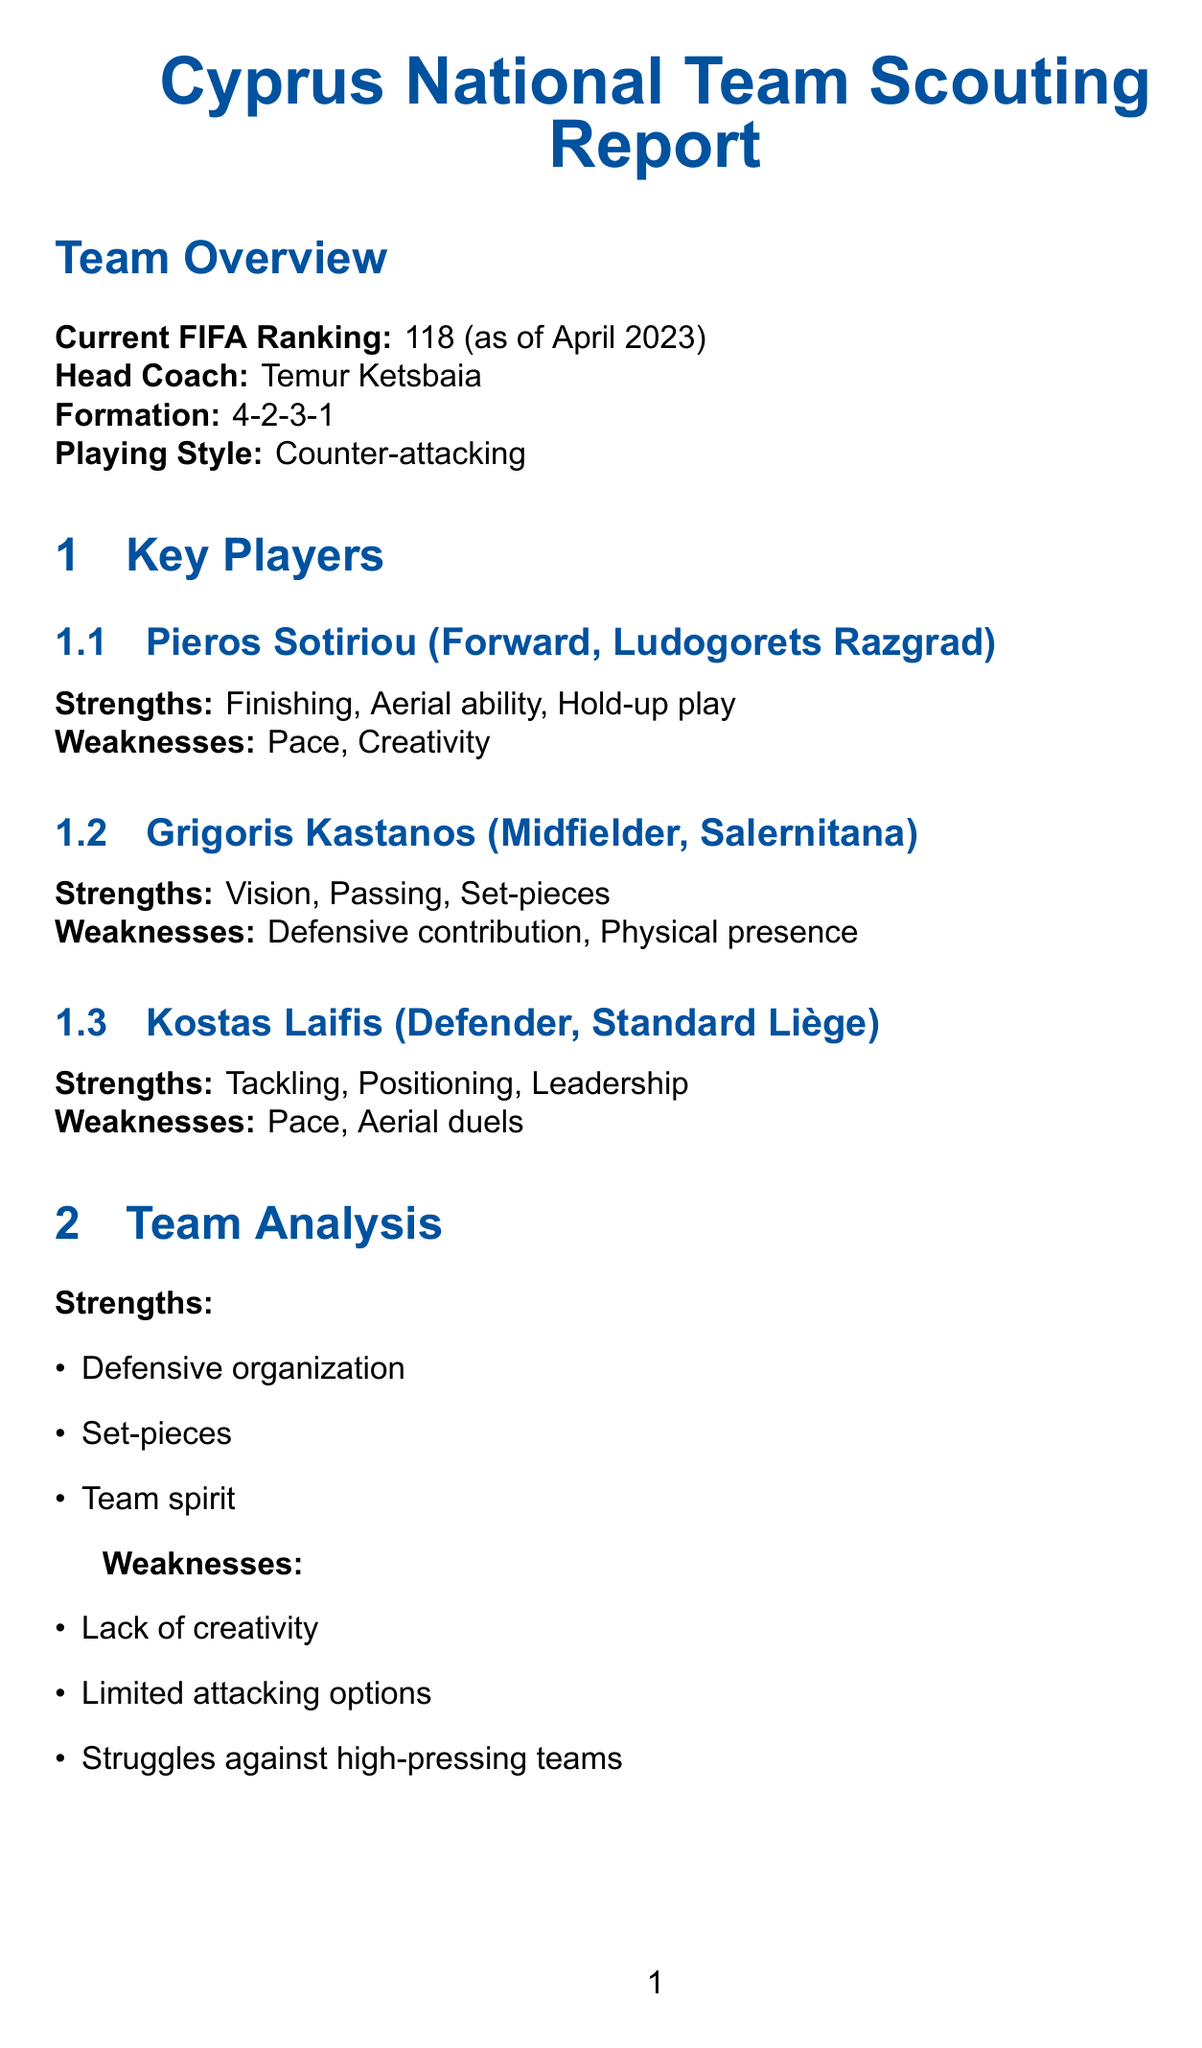what is the current FIFA ranking of the Cyprus national team? The current FIFA ranking of the Cyprus national team is stated in the document as 118 as of April 2023.
Answer: 118 who is the head coach of the Cyprus national team? The document specifies Temur Ketsbaia as the head coach of the Cyprus national team.
Answer: Temur Ketsbaia what is the formation used by the team? The document mentions the formation used by the team as 4-2-3-1.
Answer: 4-2-3-1 which player plays as a forward for Ludogorets Razgrad? The document identifies Pieros Sotiriou as the forward for Ludogorets Razgrad.
Answer: Pieros Sotiriou what are the strengths of Grigoris Kastanos? The strengths of Grigoris Kastanos, as noted in the document, include Vision, Passing, and Set-pieces.
Answer: Vision, Passing, Set-pieces what is a challenge faced by aspiring players in Cyprus? The document lists several challenges, and one of them is Limited exposure to top-level competitions.
Answer: Limited exposure to top-level competitions how many notable victories does the document list? The document lists three notable victories in the historical performance section.
Answer: 3 what is the potential impact of Loizos Loizou according to the scouting report? The scouting report mentions that Loizos Loizou has a high potential impact.
Answer: High what recent result did Cyprus achieve against Scotland? The document states that Cyprus lost 3-0 against Scotland on March 25, 2023.
Answer: Lost 3-0 